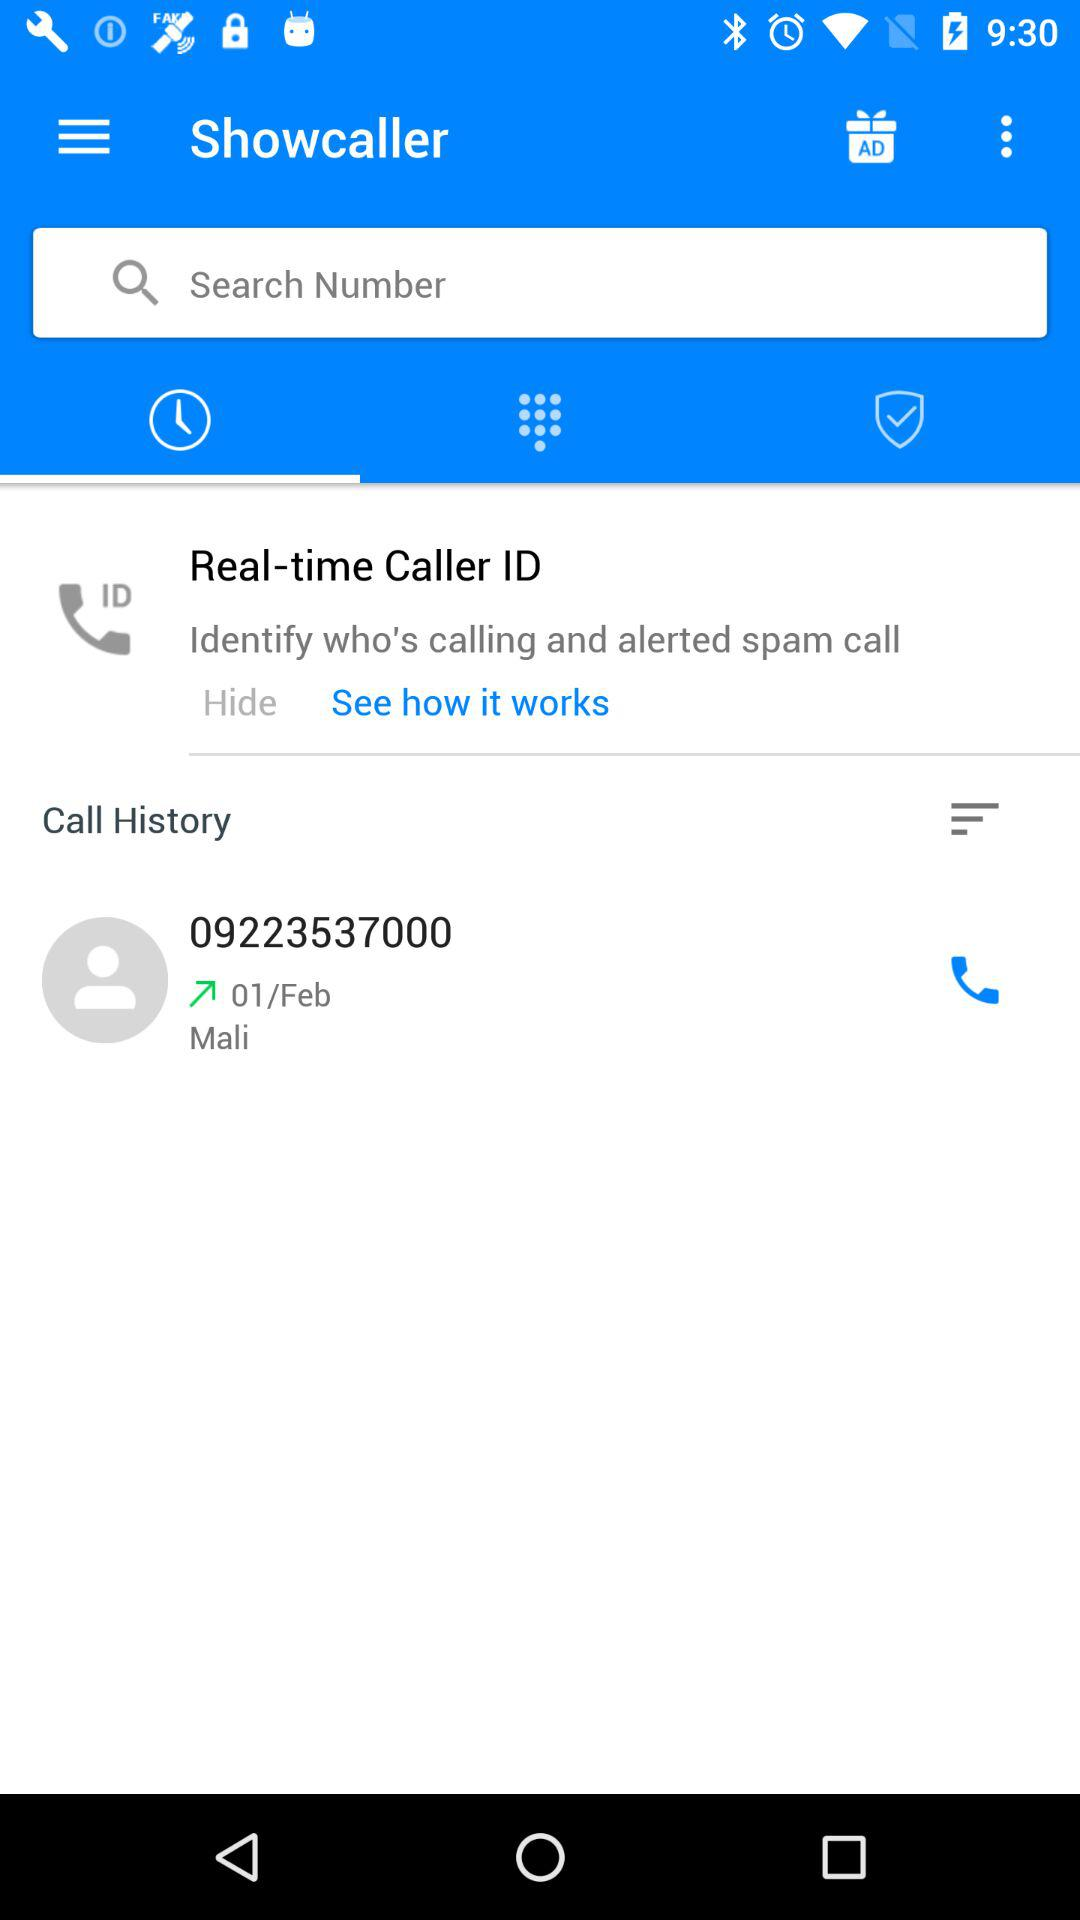What is the contact number? The contact number is 09223537000. 